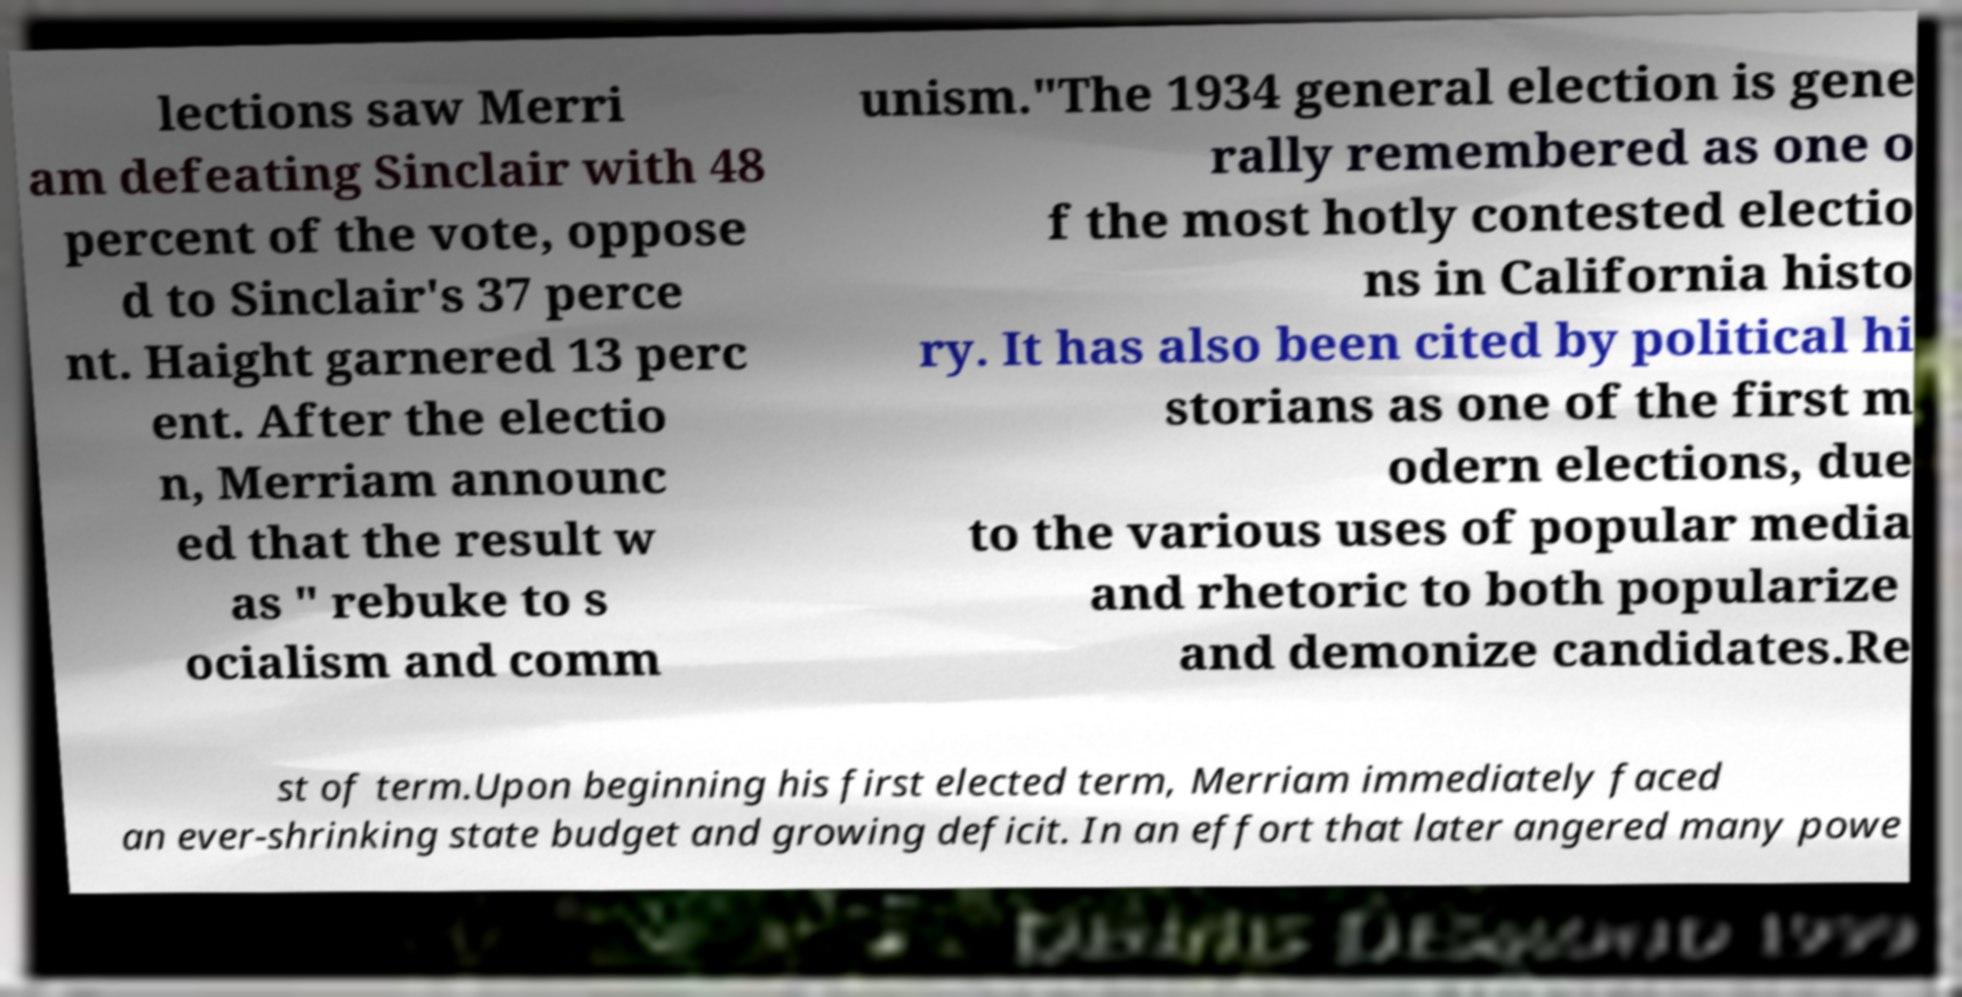Please identify and transcribe the text found in this image. lections saw Merri am defeating Sinclair with 48 percent of the vote, oppose d to Sinclair's 37 perce nt. Haight garnered 13 perc ent. After the electio n, Merriam announc ed that the result w as " rebuke to s ocialism and comm unism."The 1934 general election is gene rally remembered as one o f the most hotly contested electio ns in California histo ry. It has also been cited by political hi storians as one of the first m odern elections, due to the various uses of popular media and rhetoric to both popularize and demonize candidates.Re st of term.Upon beginning his first elected term, Merriam immediately faced an ever-shrinking state budget and growing deficit. In an effort that later angered many powe 